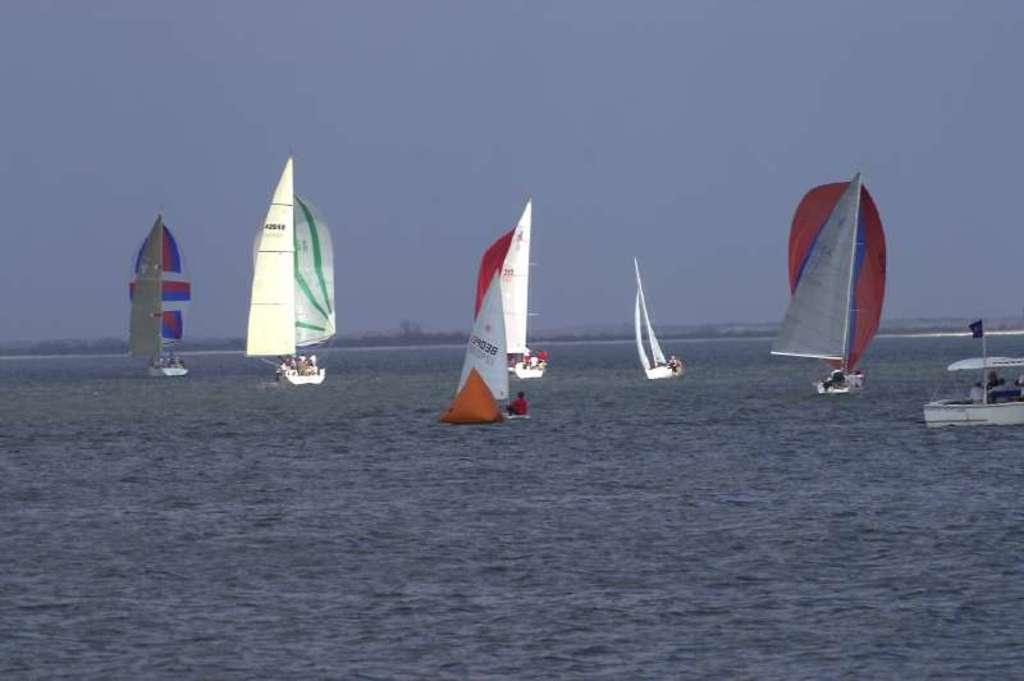What is in the front of the image? There is water in the front of the image. What can be seen in the background of the image? There are boats sailing on the water in the background. Can you describe the people in the image? There are persons inside the boats. How would you describe the sky in the image? The sky is cloudy. What time of day is it in the image, considering the presence of a zephyr? There is no mention of a zephyr in the image, and the time of day cannot be determined solely based on the presence of clouds in the sky. 